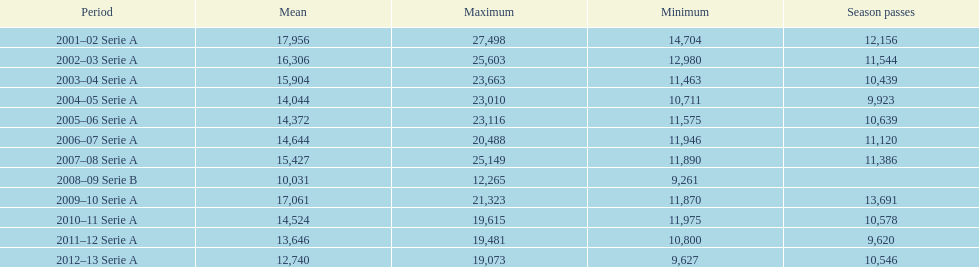How many seasons at the stadio ennio tardini had 11,000 or more season tickets? 5. 